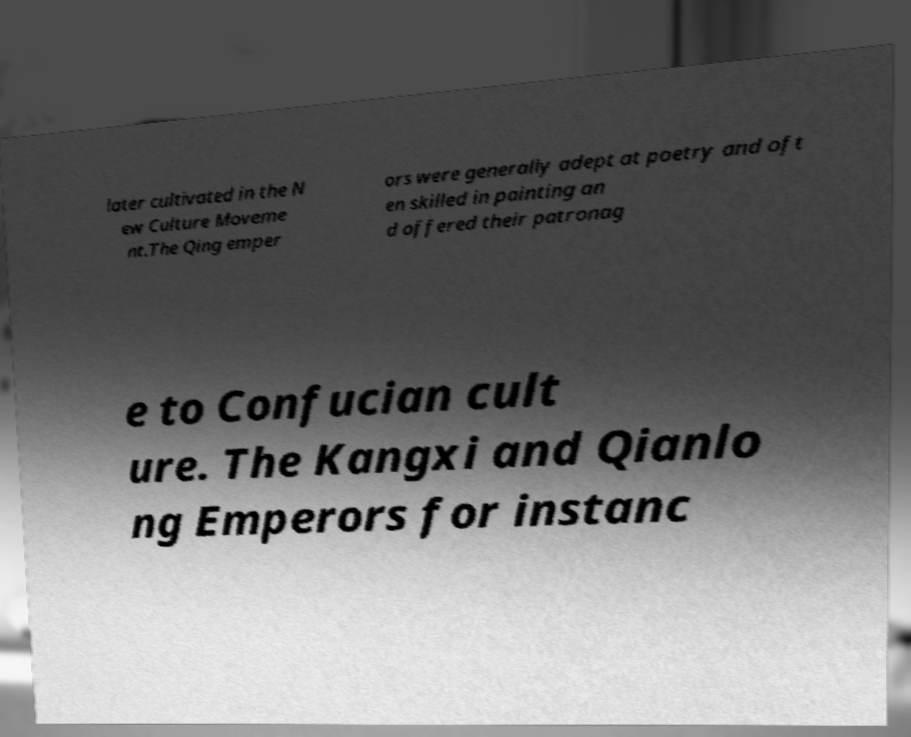Please identify and transcribe the text found in this image. later cultivated in the N ew Culture Moveme nt.The Qing emper ors were generally adept at poetry and oft en skilled in painting an d offered their patronag e to Confucian cult ure. The Kangxi and Qianlo ng Emperors for instanc 